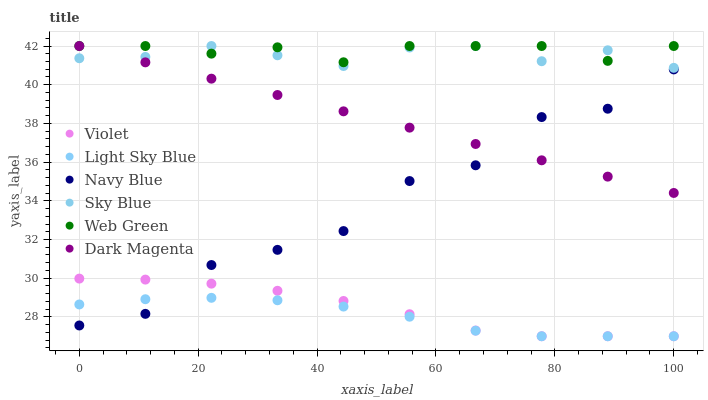Does Light Sky Blue have the minimum area under the curve?
Answer yes or no. Yes. Does Web Green have the maximum area under the curve?
Answer yes or no. Yes. Does Navy Blue have the minimum area under the curve?
Answer yes or no. No. Does Navy Blue have the maximum area under the curve?
Answer yes or no. No. Is Dark Magenta the smoothest?
Answer yes or no. Yes. Is Navy Blue the roughest?
Answer yes or no. Yes. Is Web Green the smoothest?
Answer yes or no. No. Is Web Green the roughest?
Answer yes or no. No. Does Light Sky Blue have the lowest value?
Answer yes or no. Yes. Does Navy Blue have the lowest value?
Answer yes or no. No. Does Sky Blue have the highest value?
Answer yes or no. Yes. Does Navy Blue have the highest value?
Answer yes or no. No. Is Light Sky Blue less than Web Green?
Answer yes or no. Yes. Is Web Green greater than Light Sky Blue?
Answer yes or no. Yes. Does Dark Magenta intersect Sky Blue?
Answer yes or no. Yes. Is Dark Magenta less than Sky Blue?
Answer yes or no. No. Is Dark Magenta greater than Sky Blue?
Answer yes or no. No. Does Light Sky Blue intersect Web Green?
Answer yes or no. No. 